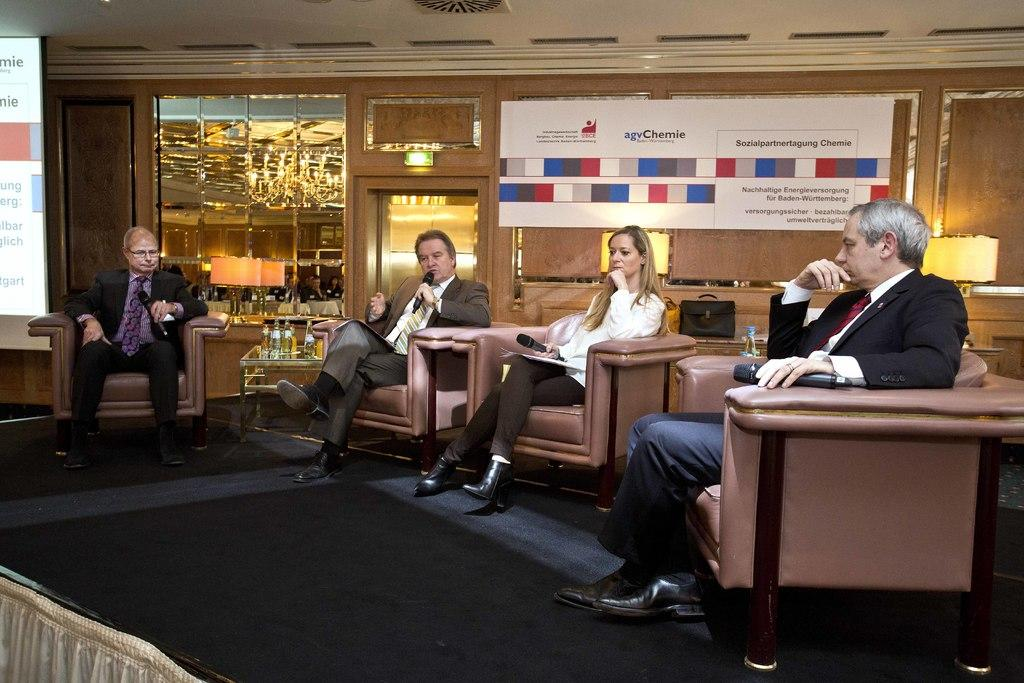How many people are sitting in the image? There are four people sitting on chairs in the image. What can be seen at the back side of the image? There is a bag and a water bottle at the back side of the image. What is the belief system of the people in the image? There is no information about the belief system of the people in the image, as it is not mentioned in the provided facts. 